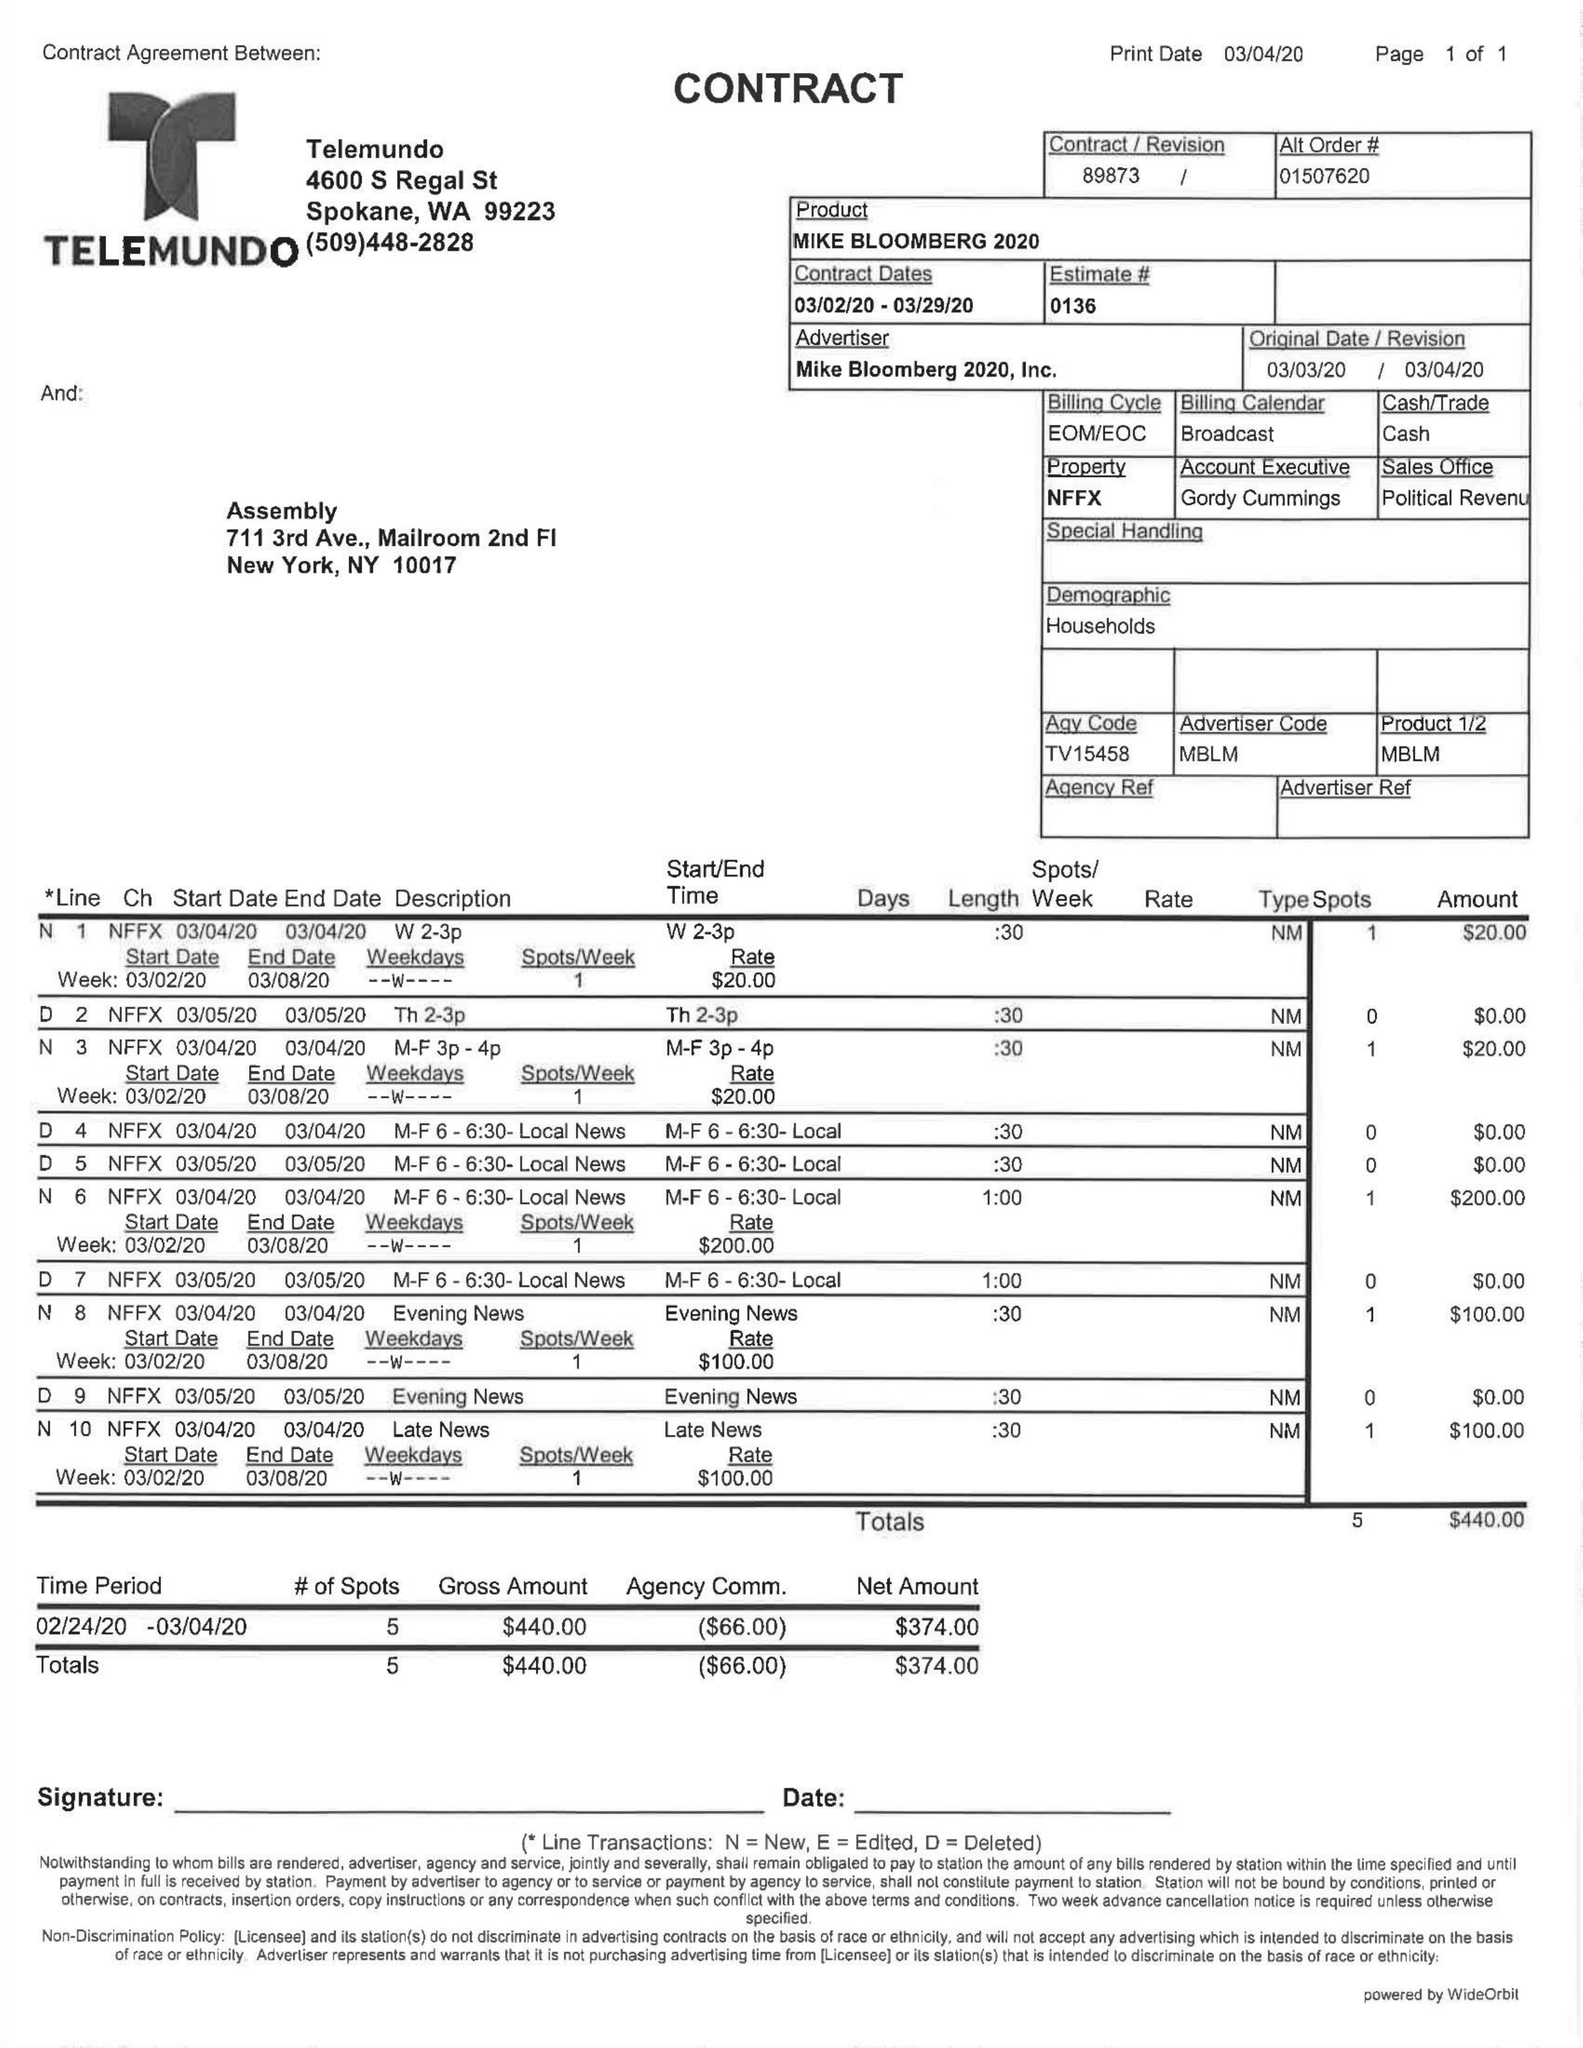What is the value for the flight_to?
Answer the question using a single word or phrase. 03/29/20 